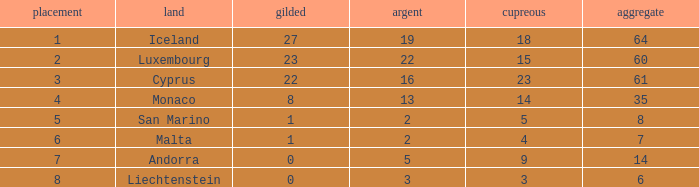Where does Iceland rank with under 19 silvers? None. 